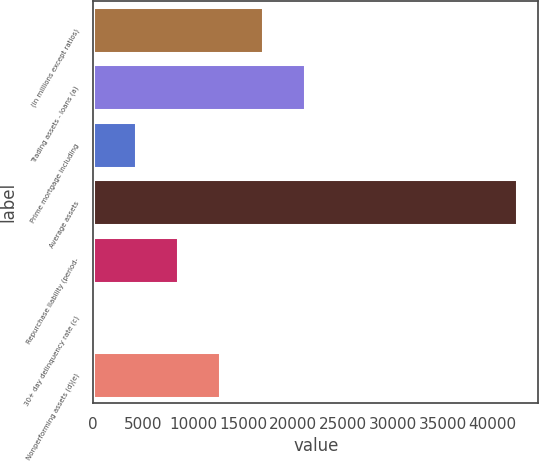Convert chart. <chart><loc_0><loc_0><loc_500><loc_500><bar_chart><fcel>(in millions except ratios)<fcel>Trading assets - loans (a)<fcel>Prime mortgage including<fcel>Average assets<fcel>Repurchase liability (period-<fcel>30+ day delinquency rate (c)<fcel>Nonperforming assets (d)(e)<nl><fcel>16983.6<fcel>21229<fcel>4247.45<fcel>42456<fcel>8492.84<fcel>2.06<fcel>12738.2<nl></chart> 